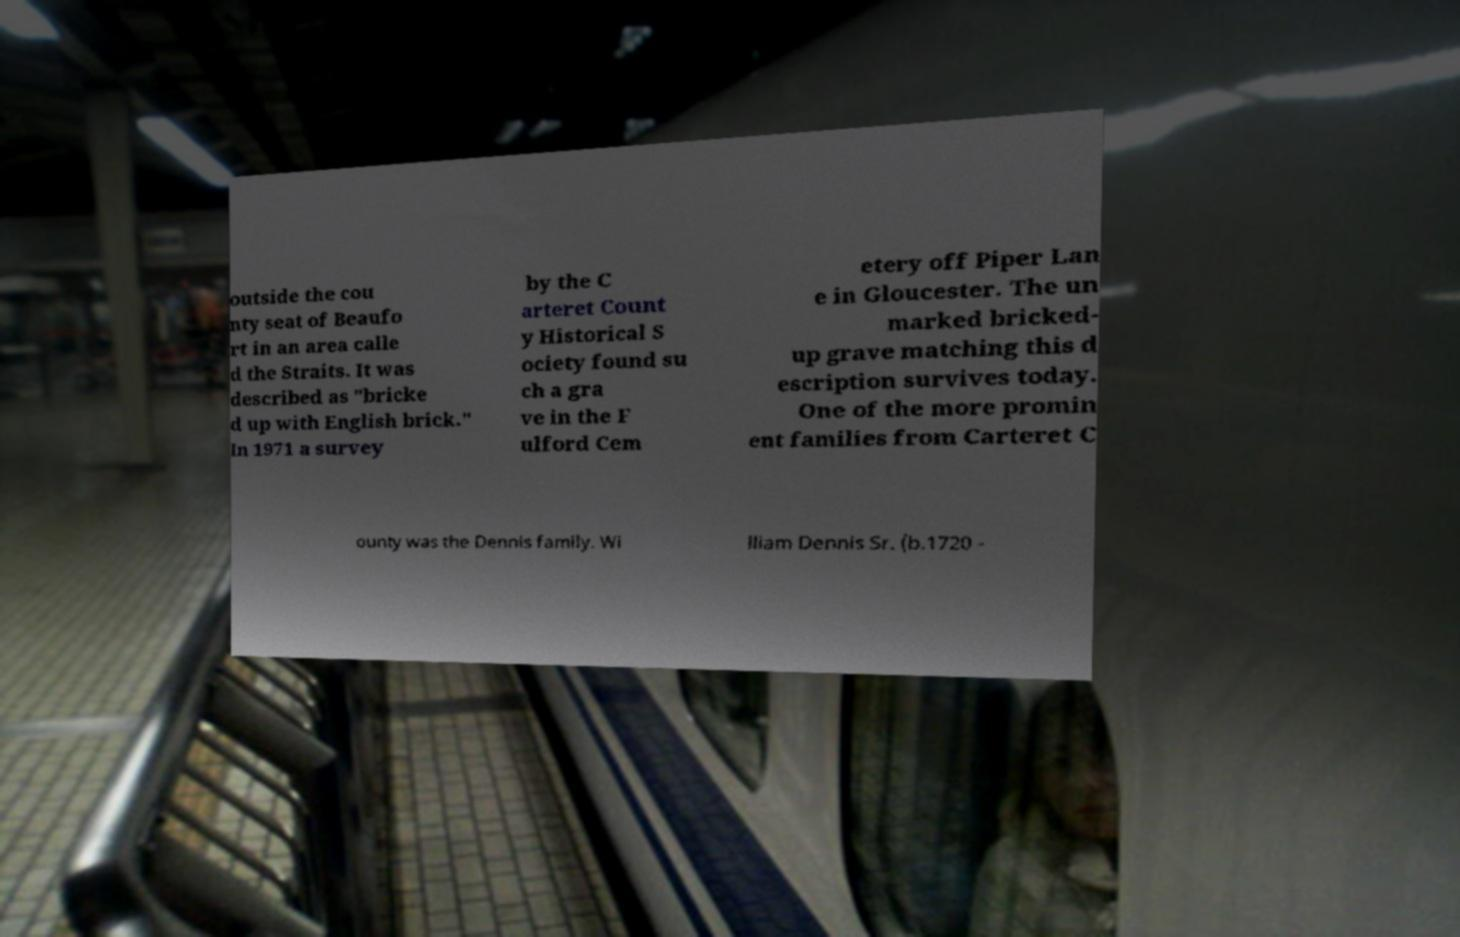Could you assist in decoding the text presented in this image and type it out clearly? outside the cou nty seat of Beaufo rt in an area calle d the Straits. It was described as "bricke d up with English brick." In 1971 a survey by the C arteret Count y Historical S ociety found su ch a gra ve in the F ulford Cem etery off Piper Lan e in Gloucester. The un marked bricked- up grave matching this d escription survives today. One of the more promin ent families from Carteret C ounty was the Dennis family. Wi lliam Dennis Sr. (b.1720 - 